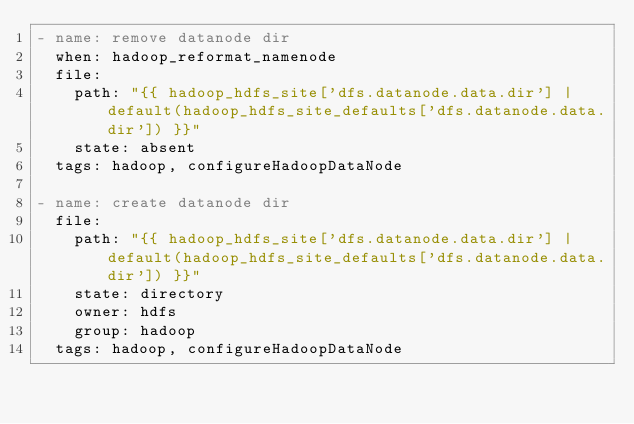<code> <loc_0><loc_0><loc_500><loc_500><_YAML_>- name: remove datanode dir
  when: hadoop_reformat_namenode
  file:
    path: "{{ hadoop_hdfs_site['dfs.datanode.data.dir'] | default(hadoop_hdfs_site_defaults['dfs.datanode.data.dir']) }}"
    state: absent
  tags: hadoop, configureHadoopDataNode

- name: create datanode dir
  file:
    path: "{{ hadoop_hdfs_site['dfs.datanode.data.dir'] | default(hadoop_hdfs_site_defaults['dfs.datanode.data.dir']) }}"
    state: directory
    owner: hdfs
    group: hadoop
  tags: hadoop, configureHadoopDataNode


</code> 